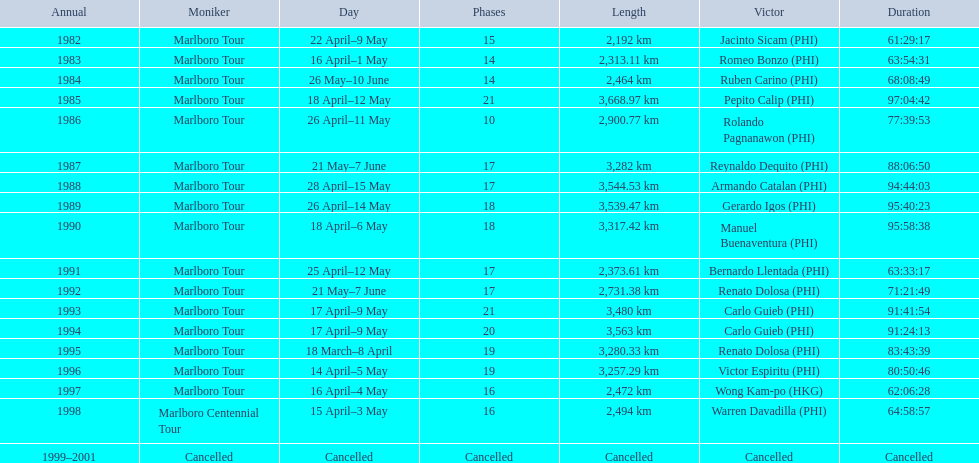What were the tour names during le tour de filipinas? Marlboro Tour, Marlboro Tour, Marlboro Tour, Marlboro Tour, Marlboro Tour, Marlboro Tour, Marlboro Tour, Marlboro Tour, Marlboro Tour, Marlboro Tour, Marlboro Tour, Marlboro Tour, Marlboro Tour, Marlboro Tour, Marlboro Tour, Marlboro Tour, Marlboro Centennial Tour, Cancelled. What were the recorded distances for each marlboro tour? 2,192 km, 2,313.11 km, 2,464 km, 3,668.97 km, 2,900.77 km, 3,282 km, 3,544.53 km, 3,539.47 km, 3,317.42 km, 2,373.61 km, 2,731.38 km, 3,480 km, 3,563 km, 3,280.33 km, 3,257.29 km, 2,472 km. And of those distances, which was the longest? 3,668.97 km. 